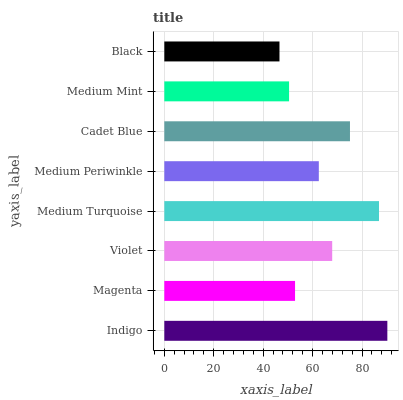Is Black the minimum?
Answer yes or no. Yes. Is Indigo the maximum?
Answer yes or no. Yes. Is Magenta the minimum?
Answer yes or no. No. Is Magenta the maximum?
Answer yes or no. No. Is Indigo greater than Magenta?
Answer yes or no. Yes. Is Magenta less than Indigo?
Answer yes or no. Yes. Is Magenta greater than Indigo?
Answer yes or no. No. Is Indigo less than Magenta?
Answer yes or no. No. Is Violet the high median?
Answer yes or no. Yes. Is Medium Periwinkle the low median?
Answer yes or no. Yes. Is Indigo the high median?
Answer yes or no. No. Is Violet the low median?
Answer yes or no. No. 